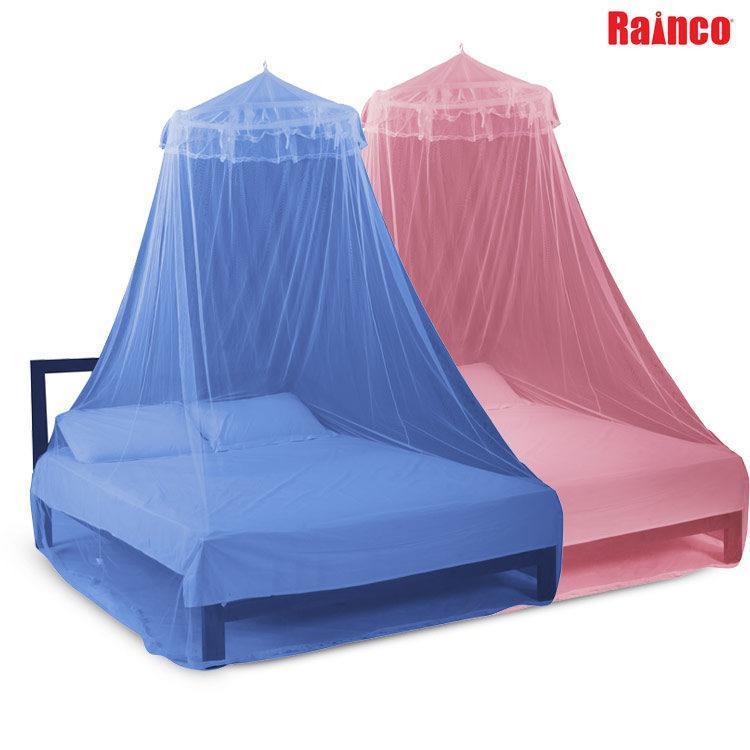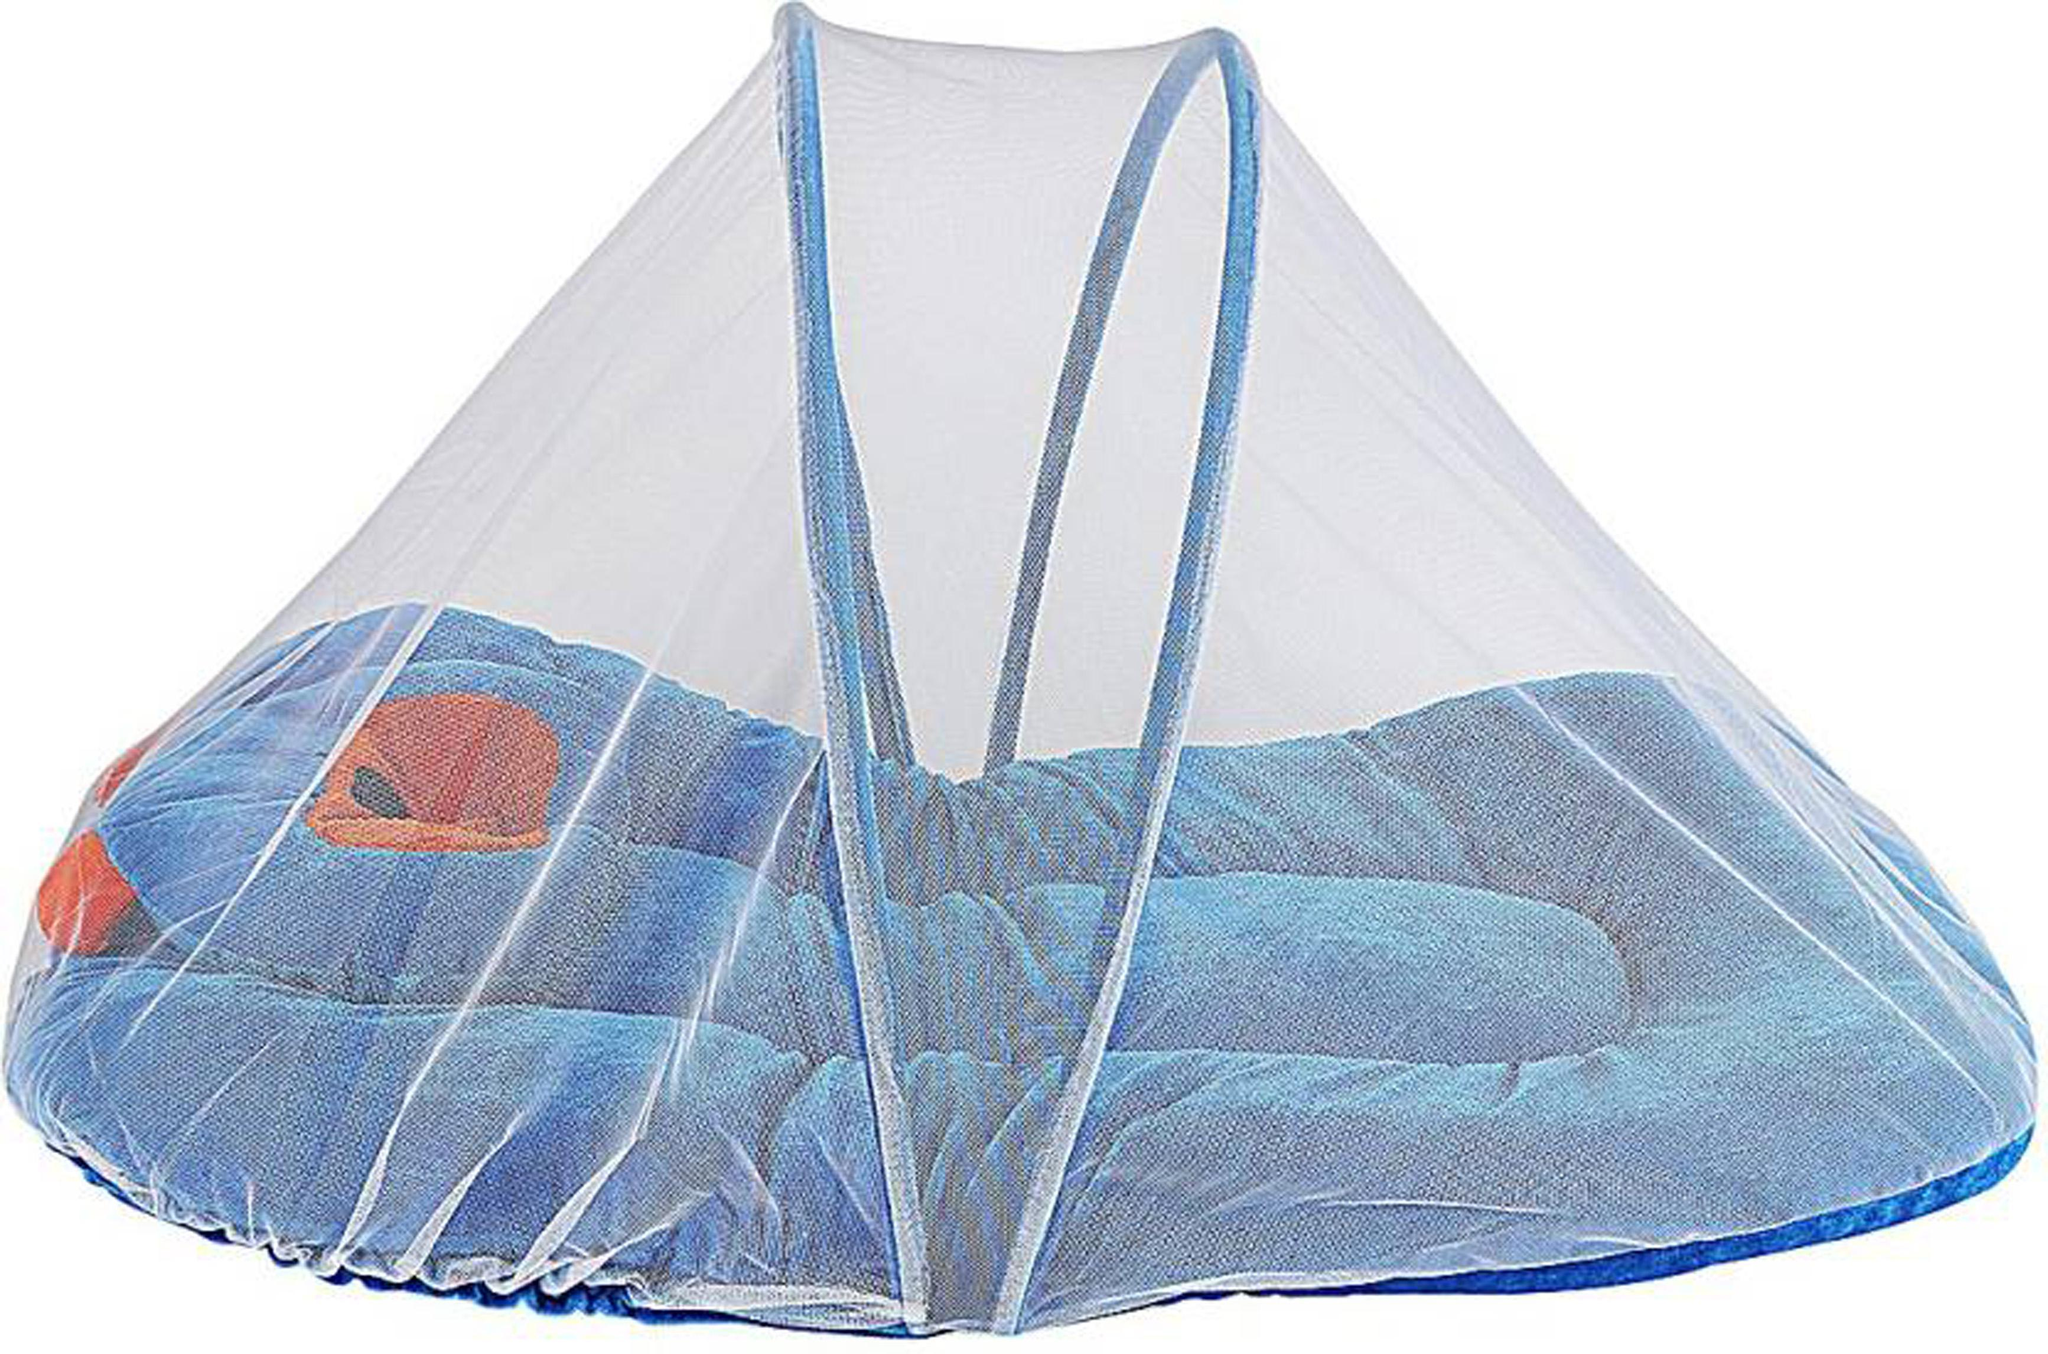The first image is the image on the left, the second image is the image on the right. Analyze the images presented: Is the assertion "One bed netting is pink." valid? Answer yes or no. Yes. The first image is the image on the left, the second image is the image on the right. Analyze the images presented: Is the assertion "Each image shows a bed with a dome-shaped canopy over its mattress like a tent, and at least one canopy has blue edges." valid? Answer yes or no. No. 